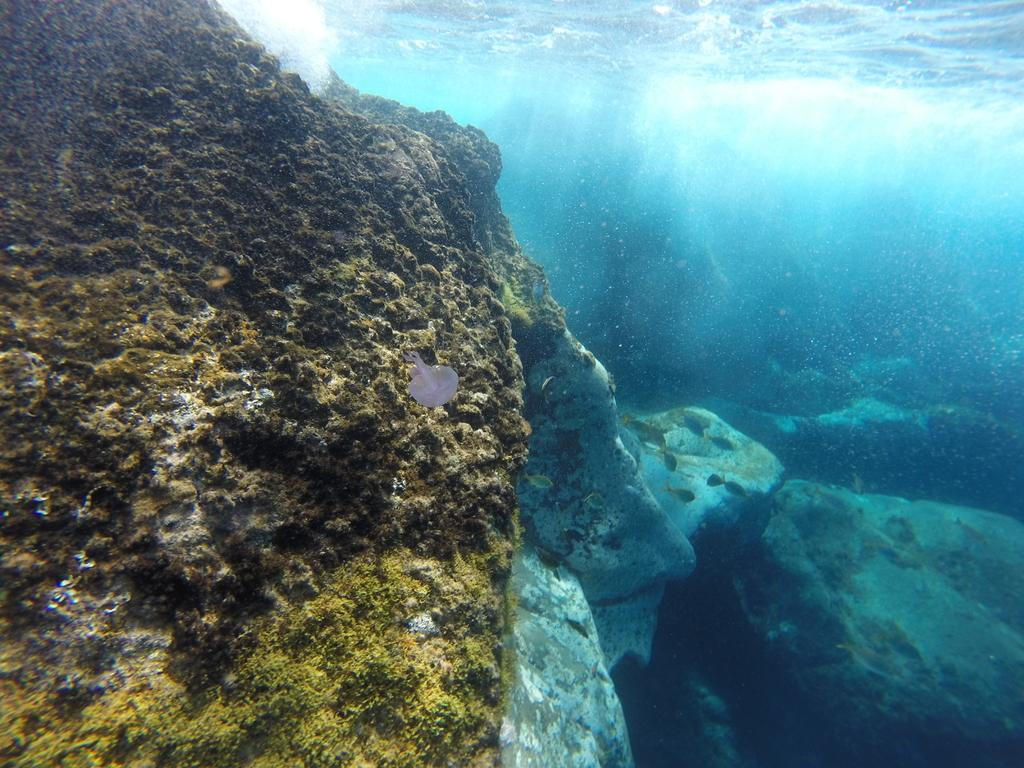What type of environment is depicted in the image? The image is an underwater view. Can you describe any specific features of the underwater environment? Unfortunately, the provided facts do not give any specific details about the underwater environment. What type of celery is being produced in the image? There is no celery present in the image, as it is an underwater view. 